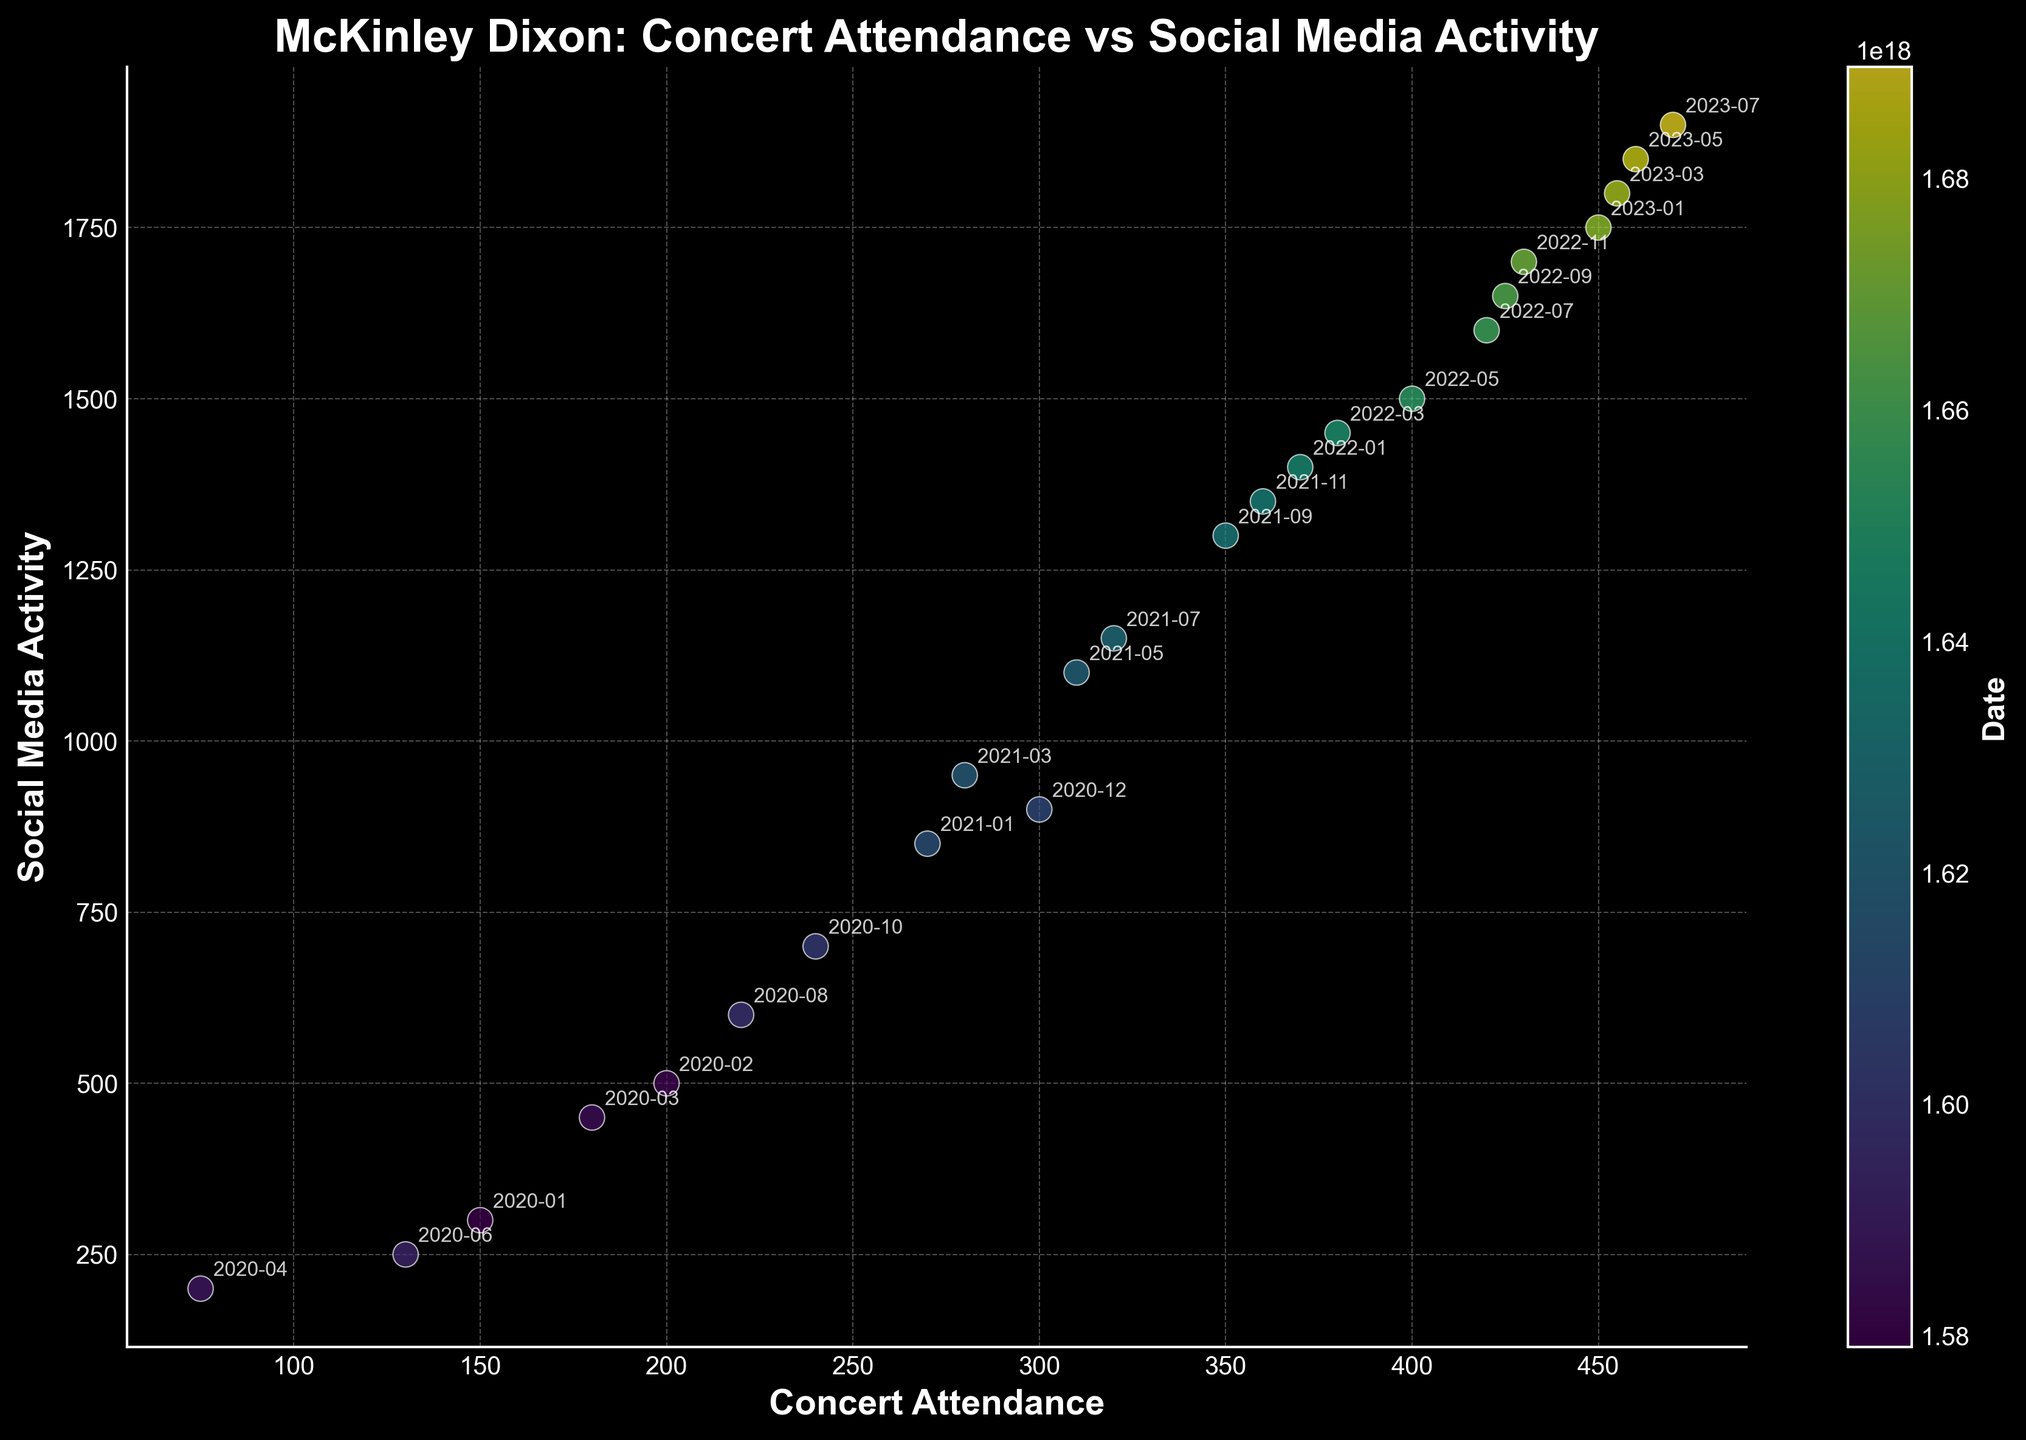What is the title of the scatter plot? The title is prominently displayed at the top of the figure. It reads "McKinley Dixon: Concert Attendance vs Social Media Activity."
Answer: McKinley Dixon: Concert Attendance vs Social Media Activity How many data points are there in the scatter plot? Count the number of distinct scatter points plotted on the figure. Each scatter point represents one data point. There are 24 data points, corresponding to the 24 dates listed.
Answer: 24 What does the color of the scatter points represent? The color of the scatter points is mapped using an internal color bar labeled "Date". This means the color intensity changes with the date, transitioning from earlier to later dates.
Answer: Date What are the units on the x-axis and y-axis? The x-axis is labeled "Concert Attendance", referring to the number of attendees at concerts. The y-axis is labeled "Social Media Activity", referring to the level of activity on social media.
Answer: Concert Attendance and Social Media Activity When was the highest spike in concert attendance and what was the corresponding social media activity? The highest concert attendance is represented by the point farthest along the x-axis, in this case, 470 attendees, which corresponds to the date "2023-07-18" with a social media activity level of 1900.
Answer: 2023-07-18 with 1900 social media activity Which month and year shows the lowest concert attendance and what is the related social media activity? Find the point positioned the furthest down on the x-axis, which is 75 attendees, corresponding to the date "2020-04-22" in the graphic. It corresponds to a social media activity level of 200.
Answer: 2020-04-22 with 200 social media activity Is there a clear correlation between concert attendance and social media activity over time? Observing the scatter plot, as concert attendance increases, social media activity also shows an increasing trend, indicating a positive correlation. Most higher attendance points are associated with higher social media activity.
Answer: Positive correlation During which period did concert attendance see significant growth? Compare time-based color gradients across the scatter points. Notice a substantial increase in concert attendance from mid-2021 onward, as evidenced by the scatter points shifting right significantly during this period.
Answer: Mid-2021 onwards How does the concert attendance and social media activity in early 2020 compare to early 2023? Compare the data points corresponding to these periods: early 2020 (e.g., Jan, Feb, Mar 2020) show concert attendances below 200, whereas early 2023 (e.g., Jan, Mar 2023) shows attendances around 450—more than doubling, with respective increases in social media activity.
Answer: Early 2023 shows much higher values Which date had the highest social media activity, and what was the concert attendance on that date? The highest point on the y-axis represents the highest social media activity, which is 1900, corresponding to "2023-07-18" with a concert attendance of 470.
Answer: 2023-07-18 with 470 concert attendance 